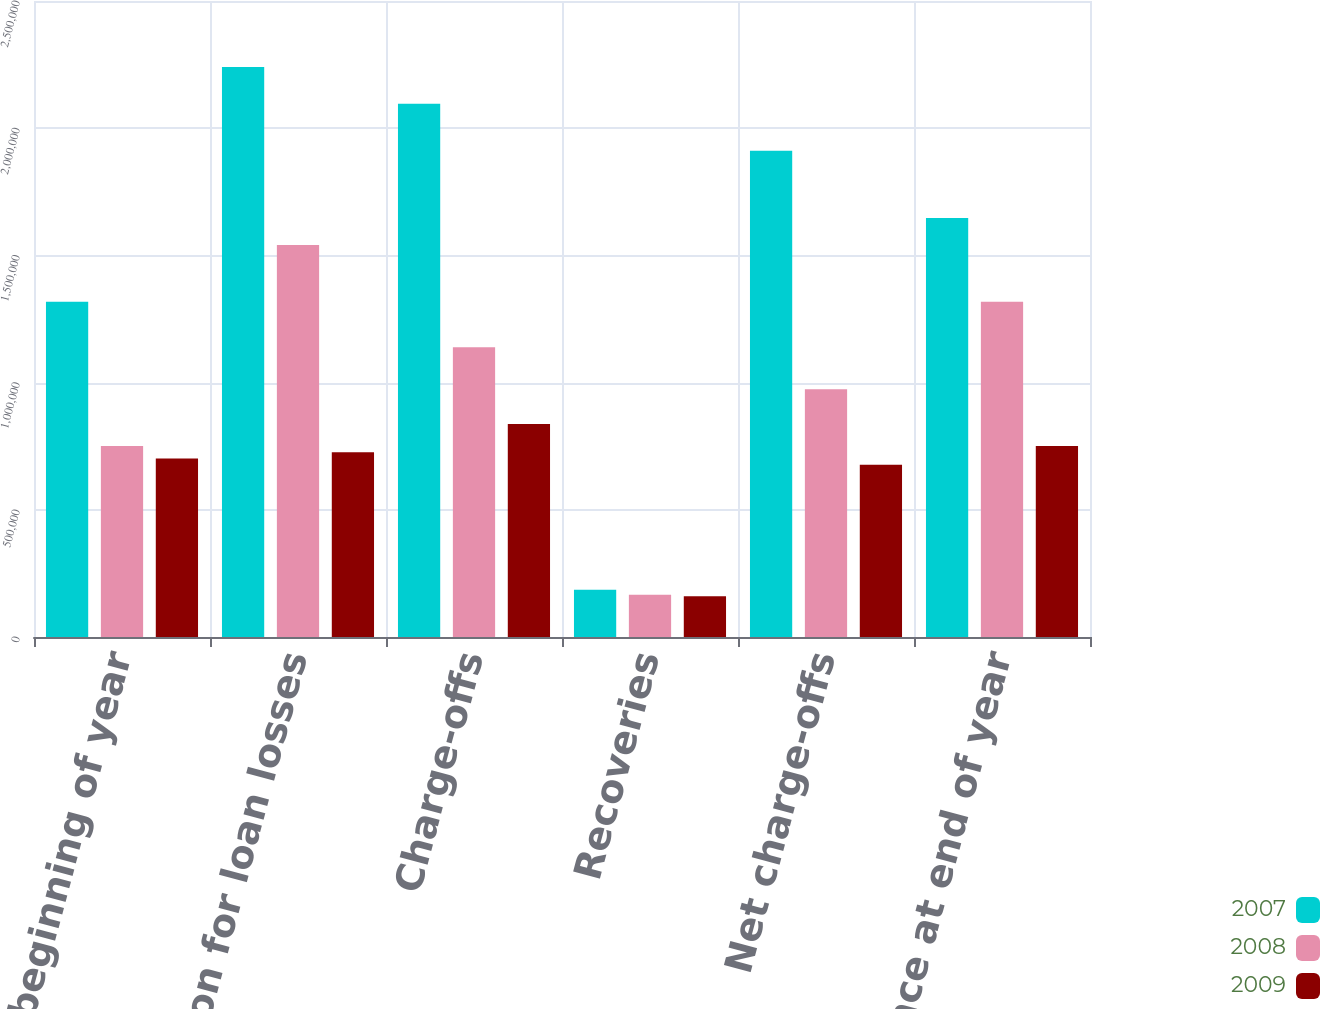Convert chart. <chart><loc_0><loc_0><loc_500><loc_500><stacked_bar_chart><ecel><fcel>Balance at beginning of year<fcel>Provision for loan losses<fcel>Charge-offs<fcel>Recoveries<fcel>Net charge-offs<fcel>Balance at end of year<nl><fcel>2007<fcel>1.31781e+06<fcel>2.24023e+06<fcel>2.09657e+06<fcel>185616<fcel>1.91096e+06<fcel>1.64709e+06<nl><fcel>2008<fcel>750786<fcel>1.54051e+06<fcel>1.13918e+06<fcel>165694<fcel>973482<fcel>1.31781e+06<nl><fcel>2009<fcel>701162<fcel>726632<fcel>837210<fcel>160202<fcel>677008<fcel>750786<nl></chart> 